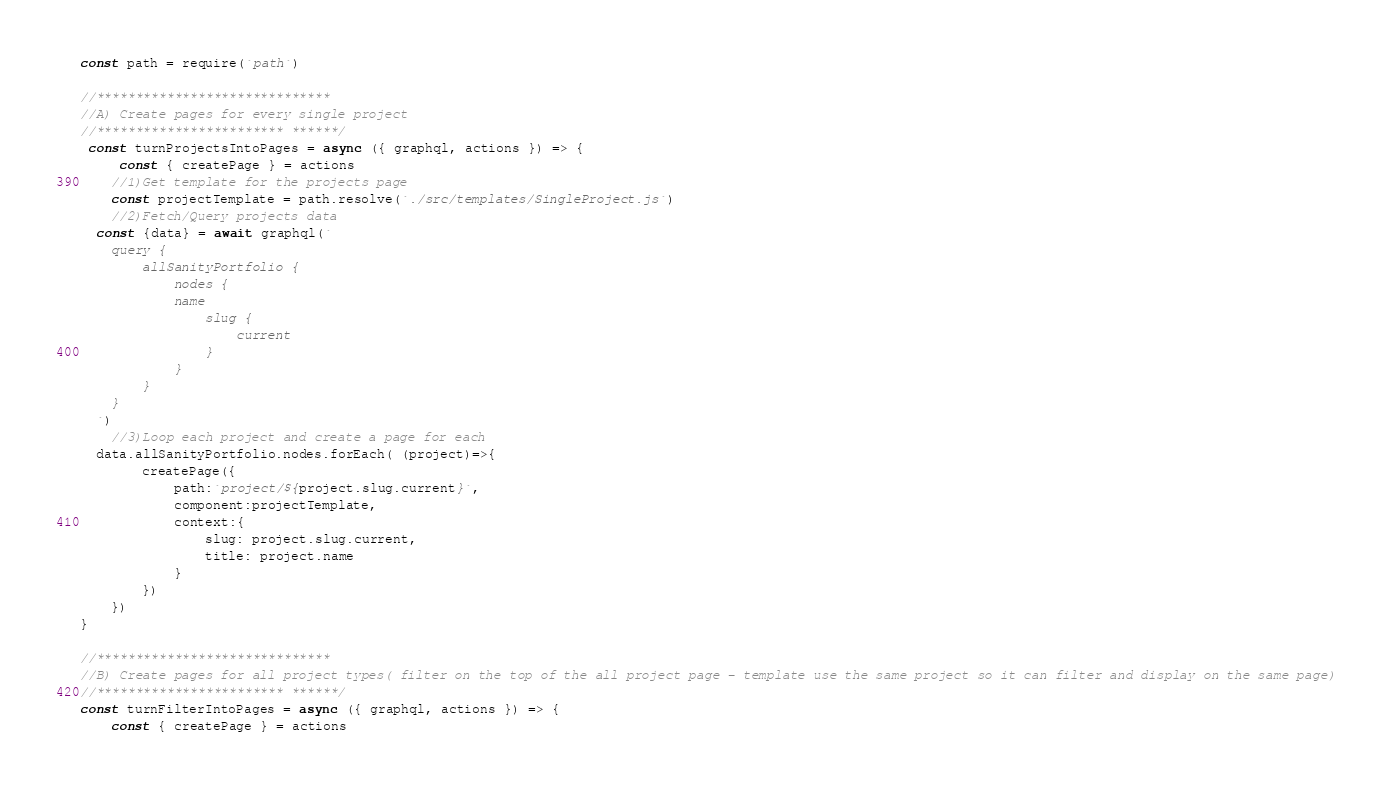<code> <loc_0><loc_0><loc_500><loc_500><_JavaScript_>const path = require(`path`)

//******************************
//A) Create pages for every single project 
//************************ ******/
 const turnProjectsIntoPages = async ({ graphql, actions }) => {
     const { createPage } = actions
    //1)Get template for the projects page
    const projectTemplate = path.resolve(`./src/templates/SingleProject.js`)
    //2)Fetch/Query projects data
  const {data} = await graphql(`
    query {
        allSanityPortfolio {
            nodes {
            name
                slug {
                    current
                }
            }
        }
    }
  `)
    //3)Loop each project and create a page for each
  data.allSanityPortfolio.nodes.forEach( (project)=>{
        createPage({
            path:`project/${project.slug.current}`,
            component:projectTemplate,
            context:{
                slug: project.slug.current,
                title: project.name
            }
        })
    })
}

//******************************
//B) Create pages for all project types( filter on the top of the all project page - template use the same project so it can filter and display on the same page)
//************************ ******/
const turnFilterIntoPages = async ({ graphql, actions }) => {
    const { createPage } = actions</code> 